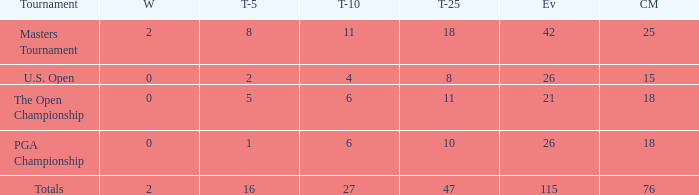What is the average top-10 for those having over 11 top-25 finishes and fewer than 2 victories? None. 